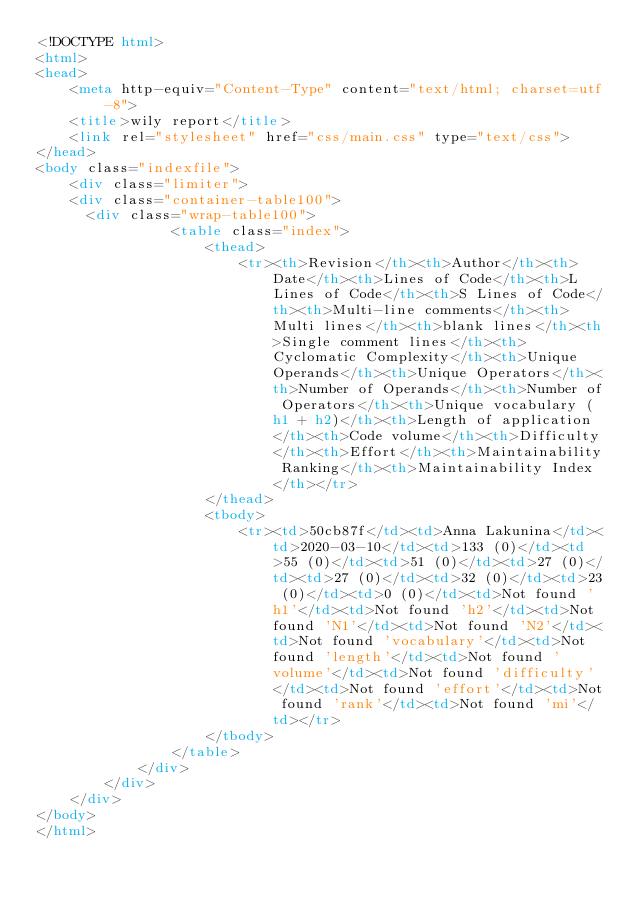Convert code to text. <code><loc_0><loc_0><loc_500><loc_500><_HTML_><!DOCTYPE html>
<html>
<head>
    <meta http-equiv="Content-Type" content="text/html; charset=utf-8">
    <title>wily report</title>
    <link rel="stylesheet" href="css/main.css" type="text/css">
</head>
<body class="indexfile">
    <div class="limiter">
		<div class="container-table100">
			<div class="wrap-table100">
                <table class="index">
                    <thead>
                        <tr><th>Revision</th><th>Author</th><th>Date</th><th>Lines of Code</th><th>L Lines of Code</th><th>S Lines of Code</th><th>Multi-line comments</th><th>Multi lines</th><th>blank lines</th><th>Single comment lines</th><th>Cyclomatic Complexity</th><th>Unique Operands</th><th>Unique Operators</th><th>Number of Operands</th><th>Number of Operators</th><th>Unique vocabulary (h1 + h2)</th><th>Length of application</th><th>Code volume</th><th>Difficulty</th><th>Effort</th><th>Maintainability Ranking</th><th>Maintainability Index</th></tr>
                    </thead>
                    <tbody>
                        <tr><td>50cb87f</td><td>Anna Lakunina</td><td>2020-03-10</td><td>133 (0)</td><td>55 (0)</td><td>51 (0)</td><td>27 (0)</td><td>27 (0)</td><td>32 (0)</td><td>23 (0)</td><td>0 (0)</td><td>Not found 'h1'</td><td>Not found 'h2'</td><td>Not found 'N1'</td><td>Not found 'N2'</td><td>Not found 'vocabulary'</td><td>Not found 'length'</td><td>Not found 'volume'</td><td>Not found 'difficulty'</td><td>Not found 'effort'</td><td>Not found 'rank'</td><td>Not found 'mi'</td></tr>
                    </tbody>
                </table>
            </div>
        </div>
    </div>
</body>
</html></code> 